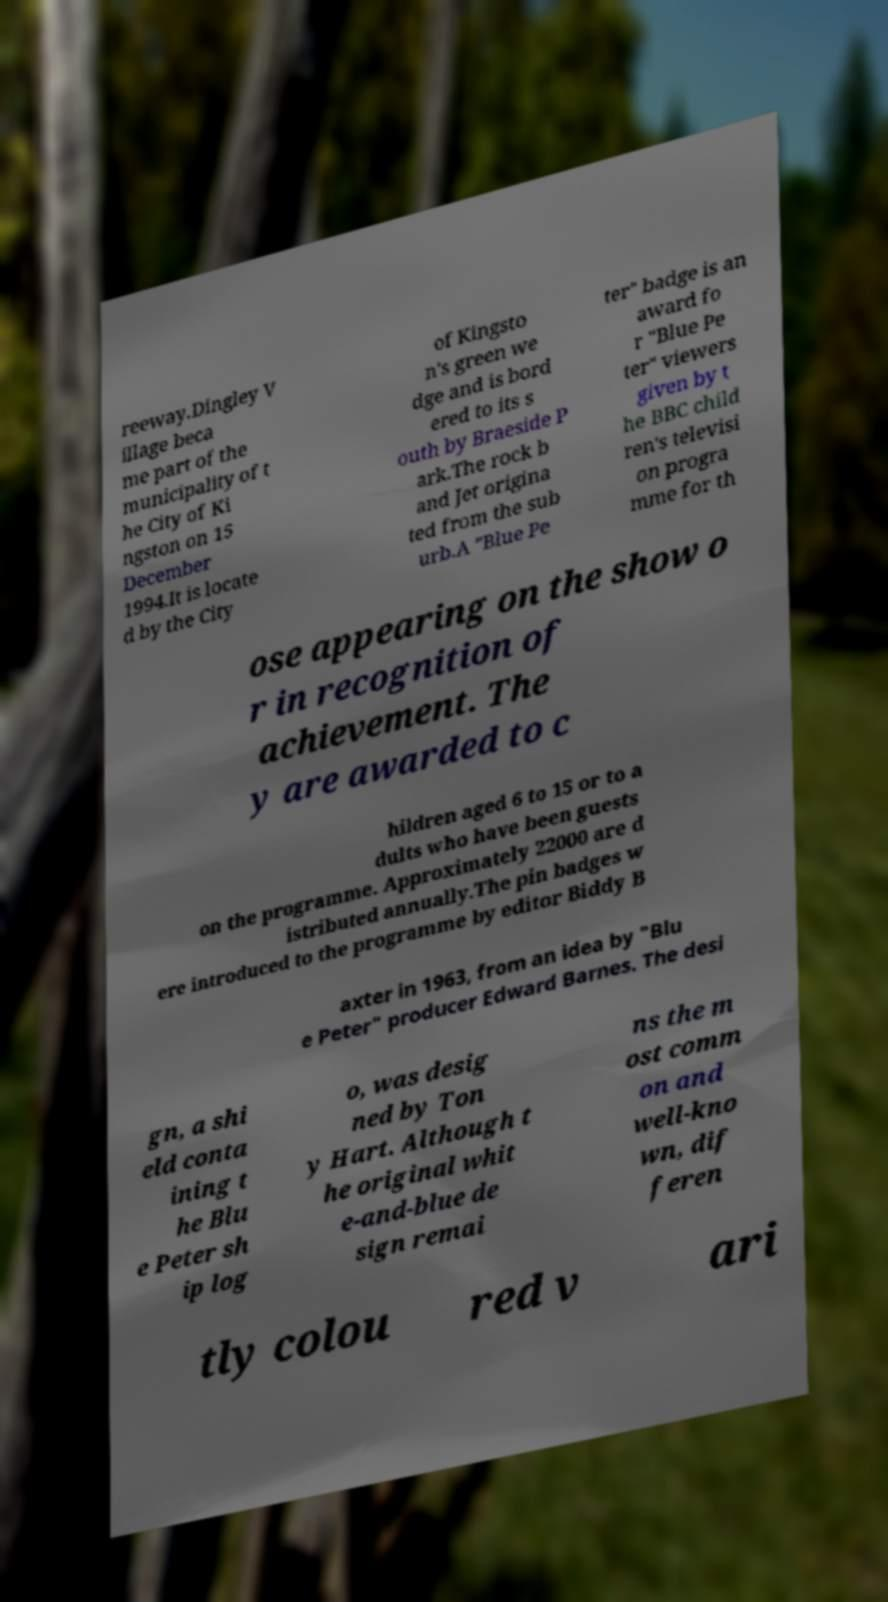Can you accurately transcribe the text from the provided image for me? reeway.Dingley V illage beca me part of the municipality of t he City of Ki ngston on 15 December 1994.It is locate d by the City of Kingsto n's green we dge and is bord ered to its s outh by Braeside P ark.The rock b and Jet origina ted from the sub urb.A "Blue Pe ter" badge is an award fo r "Blue Pe ter" viewers given by t he BBC child ren's televisi on progra mme for th ose appearing on the show o r in recognition of achievement. The y are awarded to c hildren aged 6 to 15 or to a dults who have been guests on the programme. Approximately 22000 are d istributed annually.The pin badges w ere introduced to the programme by editor Biddy B axter in 1963, from an idea by "Blu e Peter" producer Edward Barnes. The desi gn, a shi eld conta ining t he Blu e Peter sh ip log o, was desig ned by Ton y Hart. Although t he original whit e-and-blue de sign remai ns the m ost comm on and well-kno wn, dif feren tly colou red v ari 